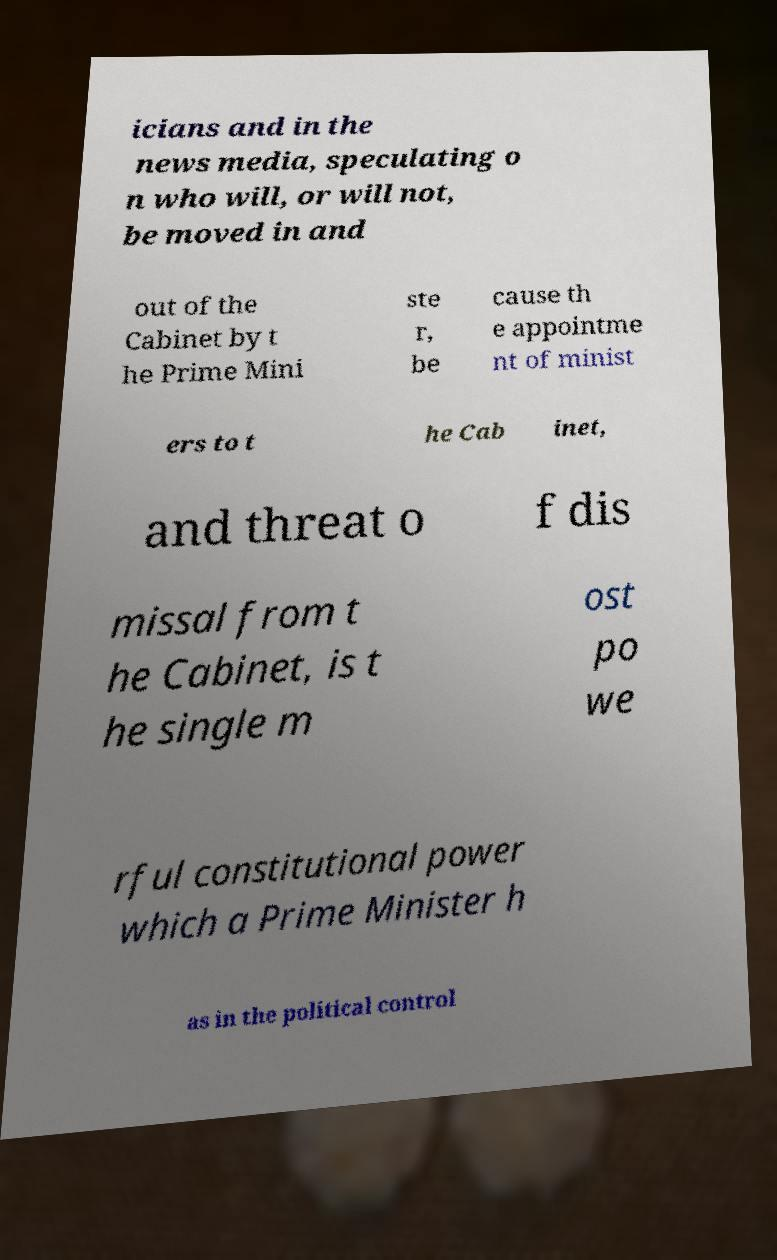What messages or text are displayed in this image? I need them in a readable, typed format. icians and in the news media, speculating o n who will, or will not, be moved in and out of the Cabinet by t he Prime Mini ste r, be cause th e appointme nt of minist ers to t he Cab inet, and threat o f dis missal from t he Cabinet, is t he single m ost po we rful constitutional power which a Prime Minister h as in the political control 